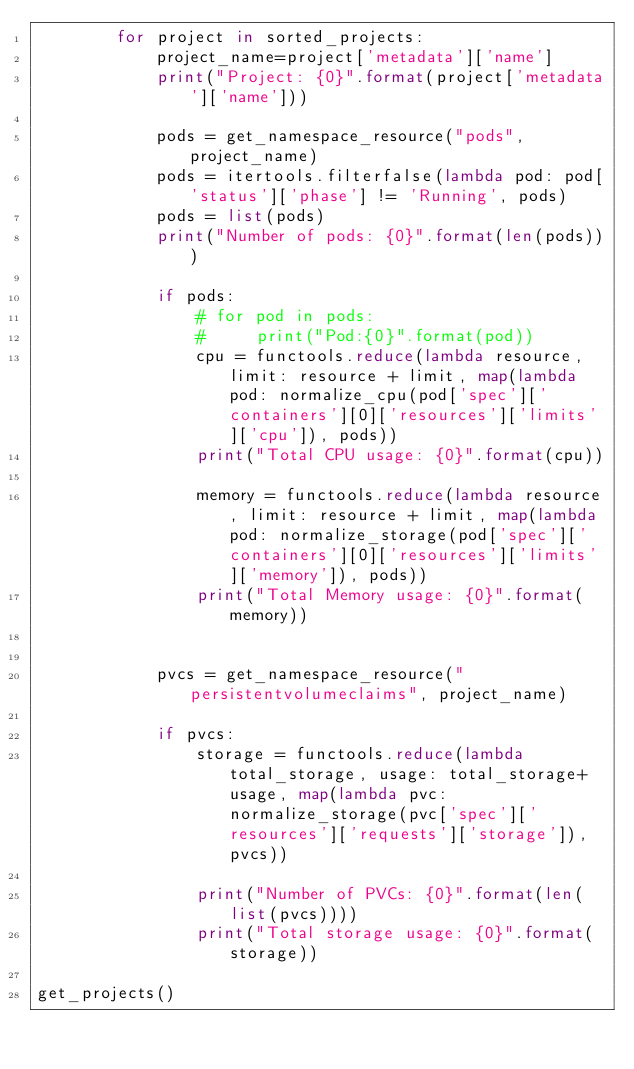<code> <loc_0><loc_0><loc_500><loc_500><_Python_>        for project in sorted_projects:
            project_name=project['metadata']['name']
            print("Project: {0}".format(project['metadata']['name']))

            pods = get_namespace_resource("pods", project_name)
            pods = itertools.filterfalse(lambda pod: pod['status']['phase'] != 'Running', pods)
            pods = list(pods)
            print("Number of pods: {0}".format(len(pods)))

            if pods:
                # for pod in pods:
                #     print("Pod:{0}".format(pod))
                cpu = functools.reduce(lambda resource, limit: resource + limit, map(lambda pod: normalize_cpu(pod['spec']['containers'][0]['resources']['limits']['cpu']), pods))
                print("Total CPU usage: {0}".format(cpu))

                memory = functools.reduce(lambda resource, limit: resource + limit, map(lambda pod: normalize_storage(pod['spec']['containers'][0]['resources']['limits']['memory']), pods))
                print("Total Memory usage: {0}".format(memory))


            pvcs = get_namespace_resource("persistentvolumeclaims", project_name)

            if pvcs:
                storage = functools.reduce(lambda total_storage, usage: total_storage+usage, map(lambda pvc: normalize_storage(pvc['spec']['resources']['requests']['storage']), pvcs))

                print("Number of PVCs: {0}".format(len(list(pvcs))))
                print("Total storage usage: {0}".format(storage))

get_projects()

</code> 